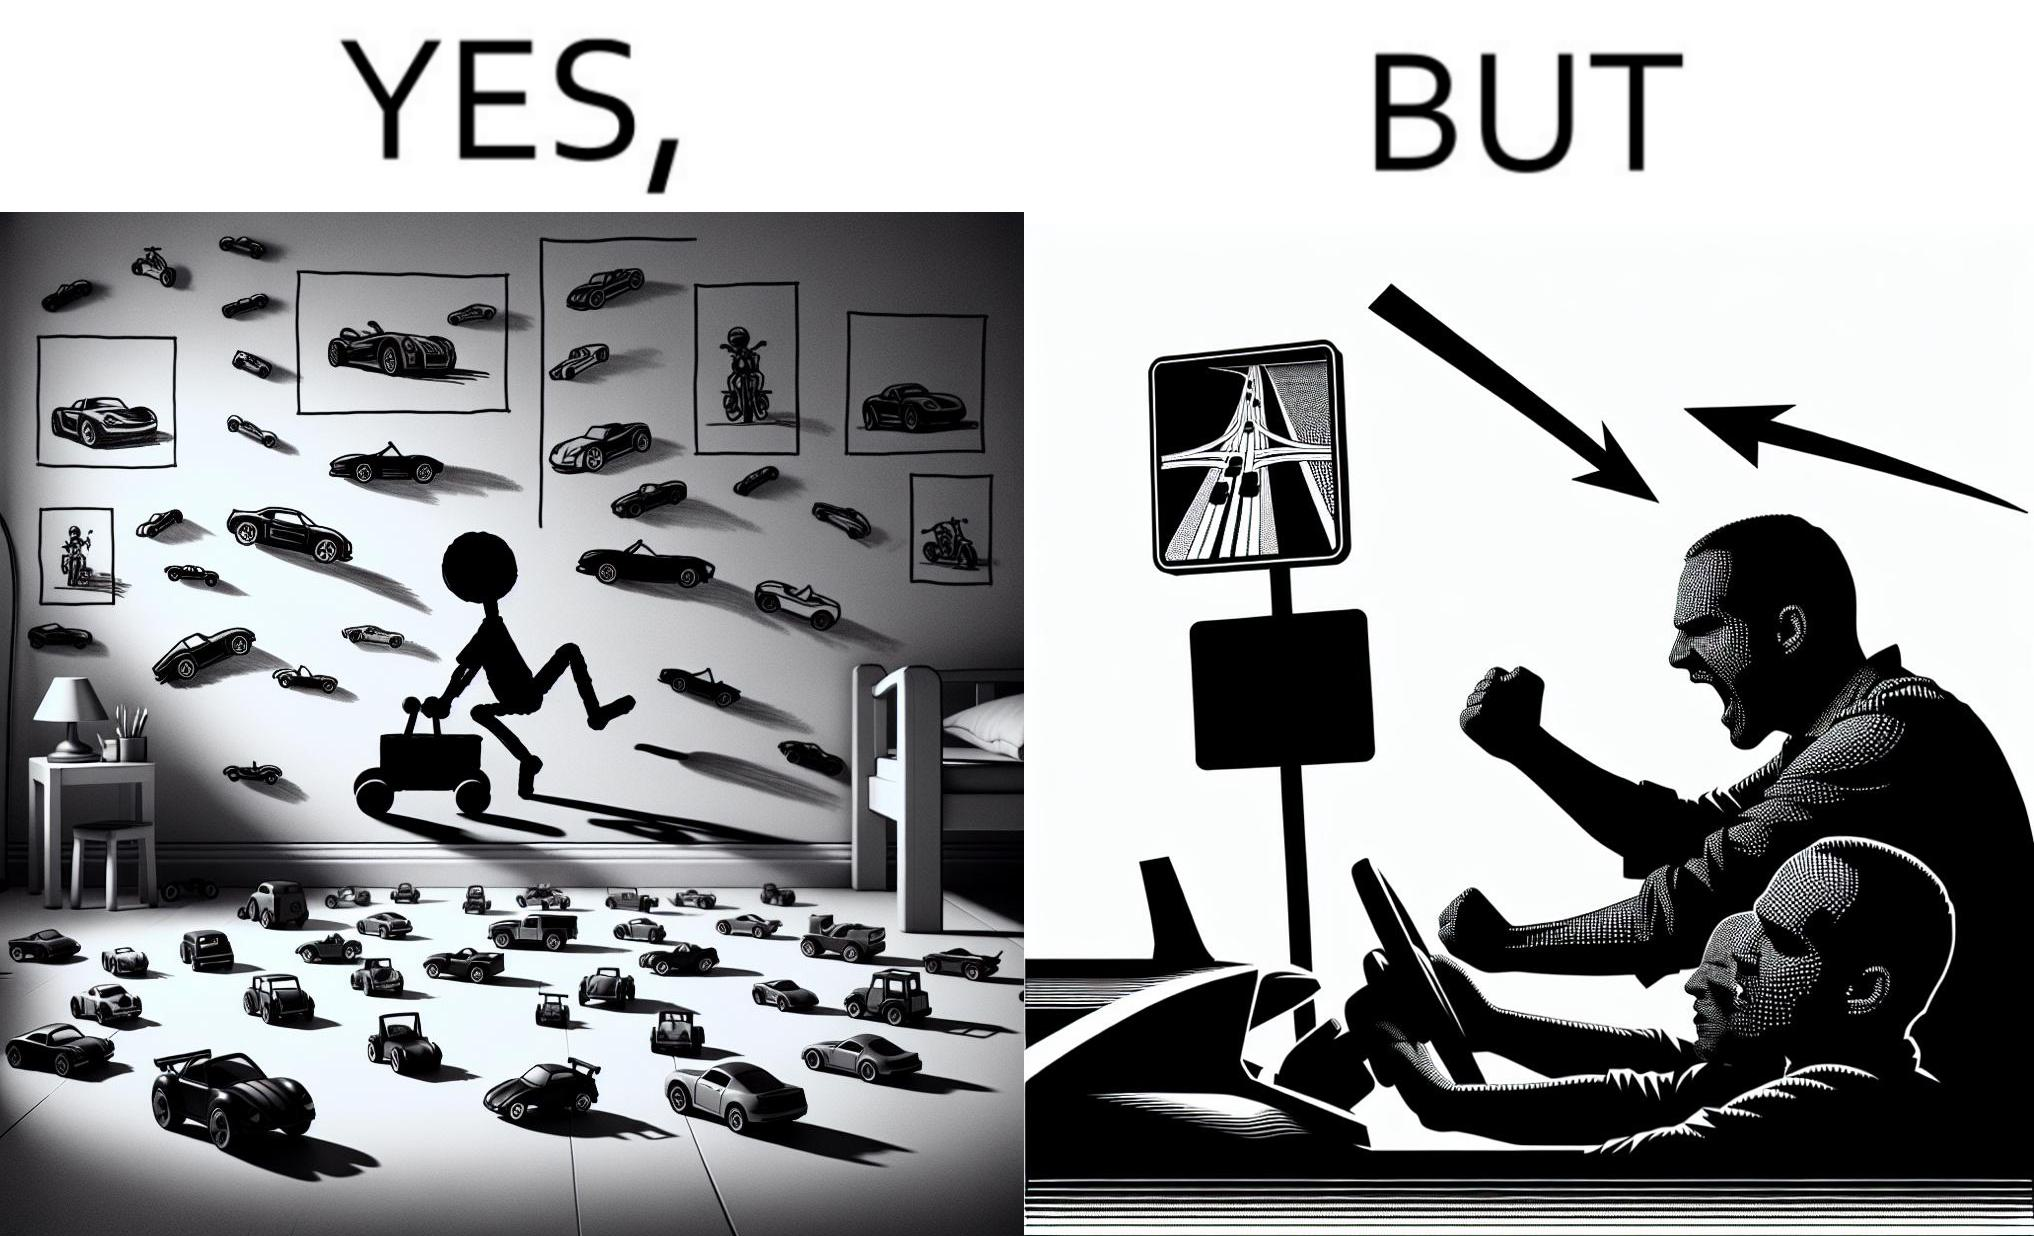Is this image satirical or non-satirical? Yes, this image is satirical. 